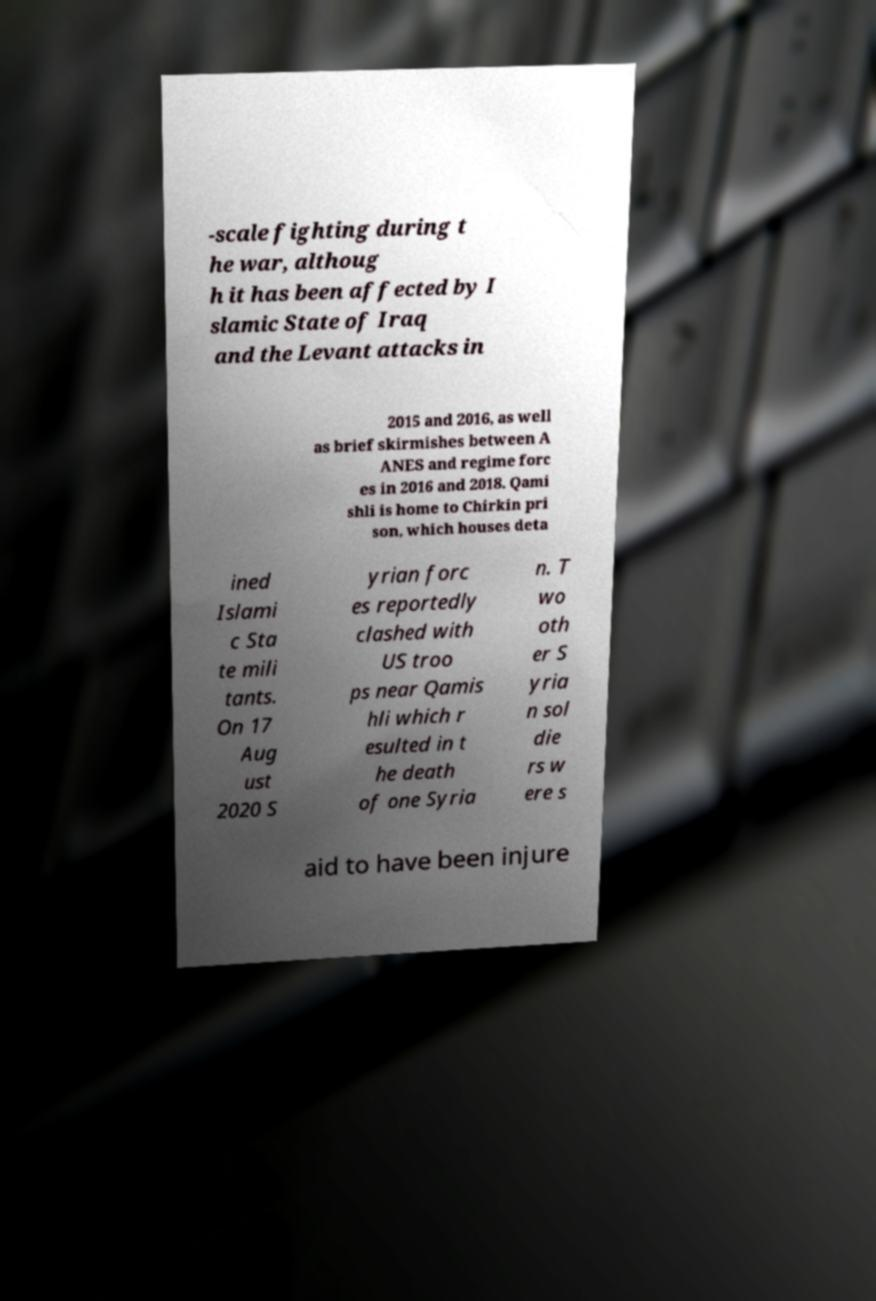I need the written content from this picture converted into text. Can you do that? -scale fighting during t he war, althoug h it has been affected by I slamic State of Iraq and the Levant attacks in 2015 and 2016, as well as brief skirmishes between A ANES and regime forc es in 2016 and 2018. Qami shli is home to Chirkin pri son, which houses deta ined Islami c Sta te mili tants. On 17 Aug ust 2020 S yrian forc es reportedly clashed with US troo ps near Qamis hli which r esulted in t he death of one Syria n. T wo oth er S yria n sol die rs w ere s aid to have been injure 